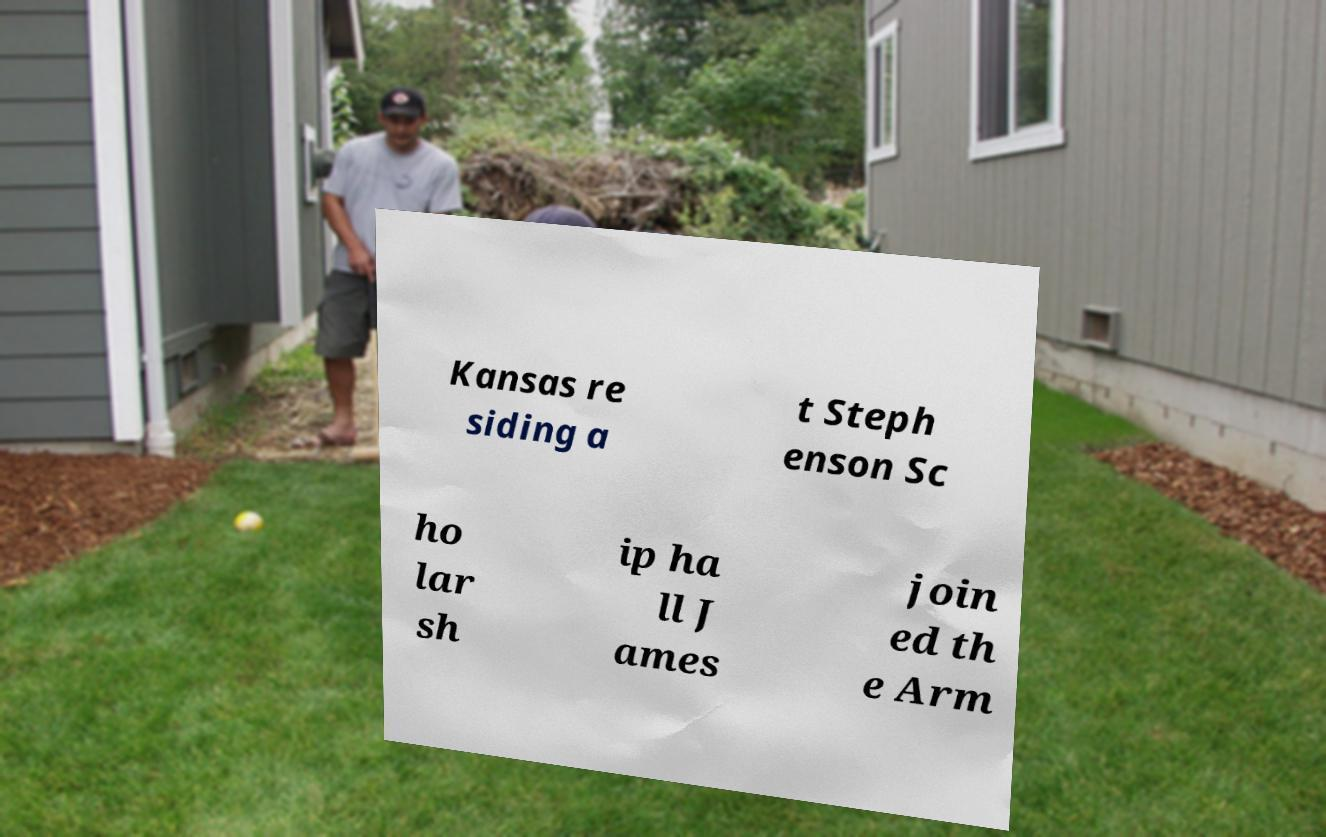Please identify and transcribe the text found in this image. Kansas re siding a t Steph enson Sc ho lar sh ip ha ll J ames join ed th e Arm 